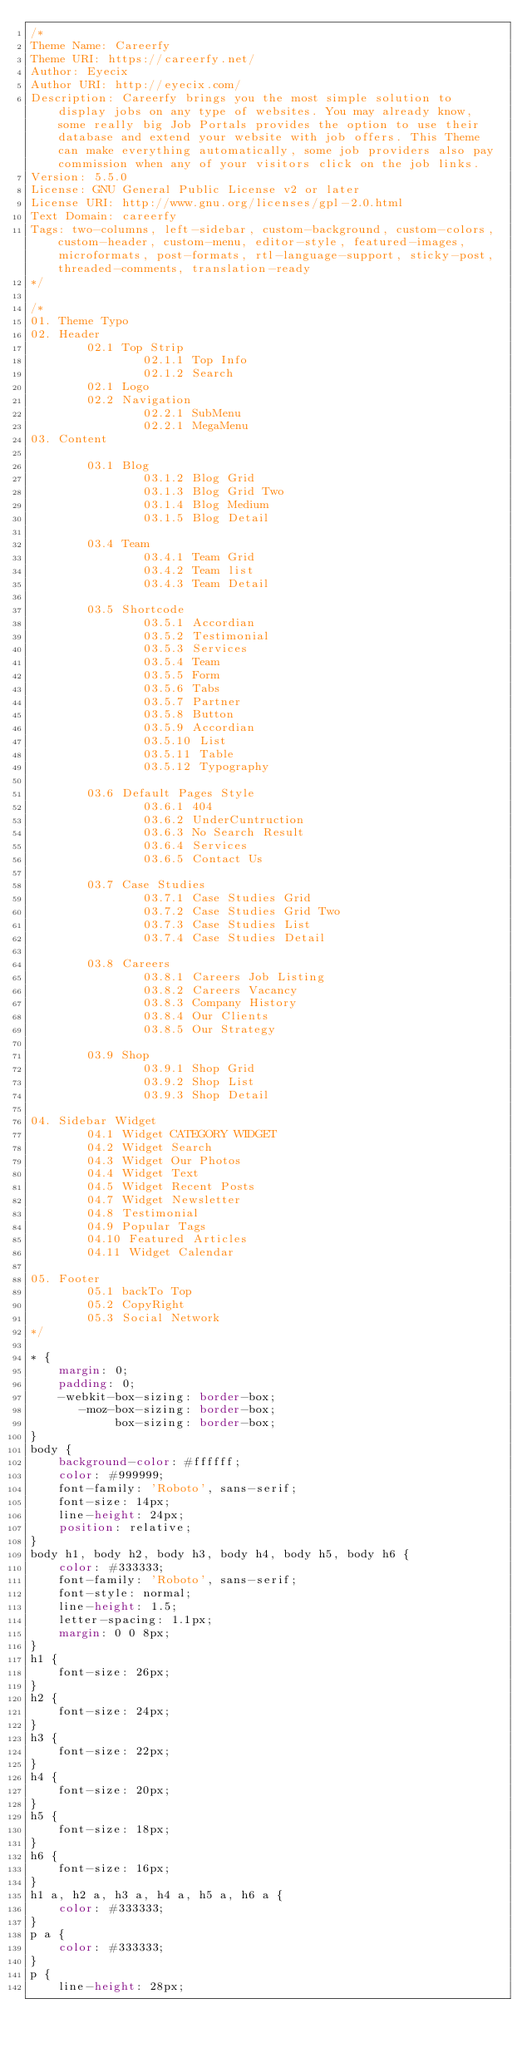Convert code to text. <code><loc_0><loc_0><loc_500><loc_500><_CSS_>/*
Theme Name: Careerfy
Theme URI: https://careerfy.net/
Author: Eyecix
Author URI: http://eyecix.com/
Description: Careerfy brings you the most simple solution to display jobs on any type of websites. You may already know, some really big Job Portals provides the option to use their database and extend your website with job offers. This Theme can make everything automatically, some job providers also pay commission when any of your visitors click on the job links.
Version: 5.5.0
License: GNU General Public License v2 or later
License URI: http://www.gnu.org/licenses/gpl-2.0.html
Text Domain: careerfy
Tags: two-columns, left-sidebar, custom-background, custom-colors, custom-header, custom-menu, editor-style, featured-images, microformats, post-formats, rtl-language-support, sticky-post, threaded-comments, translation-ready
*/

/*
01. Theme Typo
02. Header
        02.1 Top Strip
                02.1.1 Top Info
                02.1.2 Search
        02.1 Logo
        02.2 Navigation
                02.2.1 SubMenu
                02.2.1 MegaMenu
03. Content

        03.1 Blog
                03.1.2 Blog Grid
                03.1.3 Blog Grid Two
                03.1.4 Blog Medium
                03.1.5 Blog Detail
        
        03.4 Team
                03.4.1 Team Grid
                03.4.2 Team list
                03.4.3 Team Detail

        03.5 Shortcode
                03.5.1 Accordian
                03.5.2 Testimonial
                03.5.3 Services
                03.5.4 Team
                03.5.5 Form
                03.5.6 Tabs
                03.5.7 Partner
                03.5.8 Button
                03.5.9 Accordian
                03.5.10 List
                03.5.11 Table
                03.5.12 Typography
 
        03.6 Default Pages Style
                03.6.1 404
                03.6.2 UnderCuntruction
                03.6.3 No Search Result
                03.6.4 Services
                03.6.5 Contact Us

        03.7 Case Studies
                03.7.1 Case Studies Grid
                03.7.2 Case Studies Grid Two
                03.7.3 Case Studies List
                03.7.4 Case Studies Detail

        03.8 Careers
                03.8.1 Careers Job Listing
                03.8.2 Careers Vacancy
                03.8.3 Company History
                03.8.4 Our Clients
                03.8.5 Our Strategy

        03.9 Shop
                03.9.1 Shop Grid
                03.9.2 Shop List
                03.9.3 Shop Detail
 
04. Sidebar Widget
        04.1 Widget CATEGORY WIDGET
        04.2 Widget Search
        04.3 Widget Our Photos
        04.4 Widget Text
        04.5 Widget Recent Posts
        04.7 Widget Newsletter
        04.8 Testimonial
        04.9 Popular Tags
        04.10 Featured Articles
        04.11 Widget Calendar
 
05. Footer
        05.1 backTo Top
        05.2 CopyRight
        05.3 Social Network
*/

* {
    margin: 0;
    padding: 0;
    -webkit-box-sizing: border-box;
       -moz-box-sizing: border-box;
            box-sizing: border-box;
}
body {
    background-color: #ffffff;
    color: #999999;
    font-family: 'Roboto', sans-serif;
    font-size: 14px;
    line-height: 24px;
    position: relative;
}
body h1, body h2, body h3, body h4, body h5, body h6 {
    color: #333333;
    font-family: 'Roboto', sans-serif;
    font-style: normal;
    line-height: 1.5;
    letter-spacing: 1.1px;
    margin: 0 0 8px;
}
h1 {
    font-size: 26px;
}
h2 {
    font-size: 24px;
}
h3 {
    font-size: 22px;
}
h4 {
    font-size: 20px;
}
h5 {
    font-size: 18px;
}
h6 {
    font-size: 16px;
}
h1 a, h2 a, h3 a, h4 a, h5 a, h6 a {
    color: #333333;
}
p a {
    color: #333333;
}
p {
    line-height: 28px;</code> 